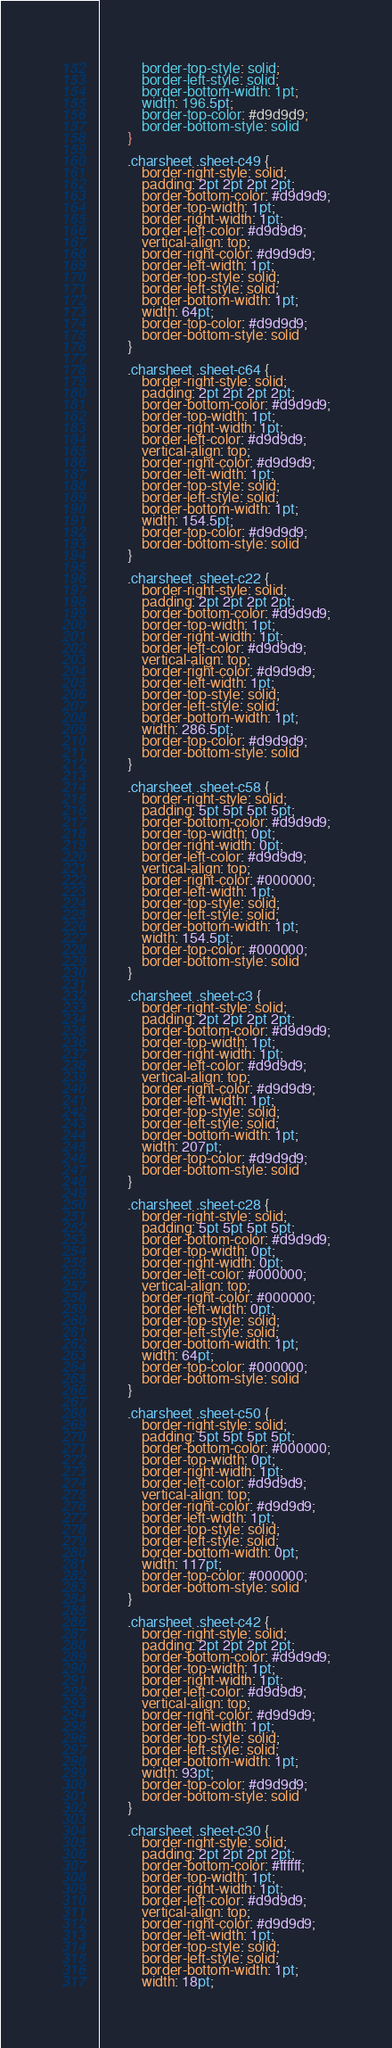Convert code to text. <code><loc_0><loc_0><loc_500><loc_500><_CSS_>            border-top-style: solid;
            border-left-style: solid;
            border-bottom-width: 1pt;
            width: 196.5pt;
            border-top-color: #d9d9d9;
            border-bottom-style: solid
        }
        
        .charsheet .sheet-c49 {
            border-right-style: solid;
            padding: 2pt 2pt 2pt 2pt;
            border-bottom-color: #d9d9d9;
            border-top-width: 1pt;
            border-right-width: 1pt;
            border-left-color: #d9d9d9;
            vertical-align: top;
            border-right-color: #d9d9d9;
            border-left-width: 1pt;
            border-top-style: solid;
            border-left-style: solid;
            border-bottom-width: 1pt;
            width: 64pt;
            border-top-color: #d9d9d9;
            border-bottom-style: solid
        }
        
        .charsheet .sheet-c64 {
            border-right-style: solid;
            padding: 2pt 2pt 2pt 2pt;
            border-bottom-color: #d9d9d9;
            border-top-width: 1pt;
            border-right-width: 1pt;
            border-left-color: #d9d9d9;
            vertical-align: top;
            border-right-color: #d9d9d9;
            border-left-width: 1pt;
            border-top-style: solid;
            border-left-style: solid;
            border-bottom-width: 1pt;
            width: 154.5pt;
            border-top-color: #d9d9d9;
            border-bottom-style: solid
        }
        
        .charsheet .sheet-c22 {
            border-right-style: solid;
            padding: 2pt 2pt 2pt 2pt;
            border-bottom-color: #d9d9d9;
            border-top-width: 1pt;
            border-right-width: 1pt;
            border-left-color: #d9d9d9;
            vertical-align: top;
            border-right-color: #d9d9d9;
            border-left-width: 1pt;
            border-top-style: solid;
            border-left-style: solid;
            border-bottom-width: 1pt;
            width: 286.5pt;
            border-top-color: #d9d9d9;
            border-bottom-style: solid
        }
        
        .charsheet .sheet-c58 {
            border-right-style: solid;
            padding: 5pt 5pt 5pt 5pt;
            border-bottom-color: #d9d9d9;
            border-top-width: 0pt;
            border-right-width: 0pt;
            border-left-color: #d9d9d9;
            vertical-align: top;
            border-right-color: #000000;
            border-left-width: 1pt;
            border-top-style: solid;
            border-left-style: solid;
            border-bottom-width: 1pt;
            width: 154.5pt;
            border-top-color: #000000;
            border-bottom-style: solid
        }
        
        .charsheet .sheet-c3 {
            border-right-style: solid;
            padding: 2pt 2pt 2pt 2pt;
            border-bottom-color: #d9d9d9;
            border-top-width: 1pt;
            border-right-width: 1pt;
            border-left-color: #d9d9d9;
            vertical-align: top;
            border-right-color: #d9d9d9;
            border-left-width: 1pt;
            border-top-style: solid;
            border-left-style: solid;
            border-bottom-width: 1pt;
            width: 207pt;
            border-top-color: #d9d9d9;
            border-bottom-style: solid
        }
        
        .charsheet .sheet-c28 {
            border-right-style: solid;
            padding: 5pt 5pt 5pt 5pt;
            border-bottom-color: #d9d9d9;
            border-top-width: 0pt;
            border-right-width: 0pt;
            border-left-color: #000000;
            vertical-align: top;
            border-right-color: #000000;
            border-left-width: 0pt;
            border-top-style: solid;
            border-left-style: solid;
            border-bottom-width: 1pt;
            width: 64pt;
            border-top-color: #000000;
            border-bottom-style: solid
        }
        
        .charsheet .sheet-c50 {
            border-right-style: solid;
            padding: 5pt 5pt 5pt 5pt;
            border-bottom-color: #000000;
            border-top-width: 0pt;
            border-right-width: 1pt;
            border-left-color: #d9d9d9;
            vertical-align: top;
            border-right-color: #d9d9d9;
            border-left-width: 1pt;
            border-top-style: solid;
            border-left-style: solid;
            border-bottom-width: 0pt;
            width: 117pt;
            border-top-color: #000000;
            border-bottom-style: solid
        }
        
        .charsheet .sheet-c42 {
            border-right-style: solid;
            padding: 2pt 2pt 2pt 2pt;
            border-bottom-color: #d9d9d9;
            border-top-width: 1pt;
            border-right-width: 1pt;
            border-left-color: #d9d9d9;
            vertical-align: top;
            border-right-color: #d9d9d9;
            border-left-width: 1pt;
            border-top-style: solid;
            border-left-style: solid;
            border-bottom-width: 1pt;
            width: 93pt;
            border-top-color: #d9d9d9;
            border-bottom-style: solid
        }
        
        .charsheet .sheet-c30 {
            border-right-style: solid;
            padding: 2pt 2pt 2pt 2pt;
            border-bottom-color: #ffffff;
            border-top-width: 1pt;
            border-right-width: 1pt;
            border-left-color: #d9d9d9;
            vertical-align: top;
            border-right-color: #d9d9d9;
            border-left-width: 1pt;
            border-top-style: solid;
            border-left-style: solid;
            border-bottom-width: 1pt;
            width: 18pt;</code> 